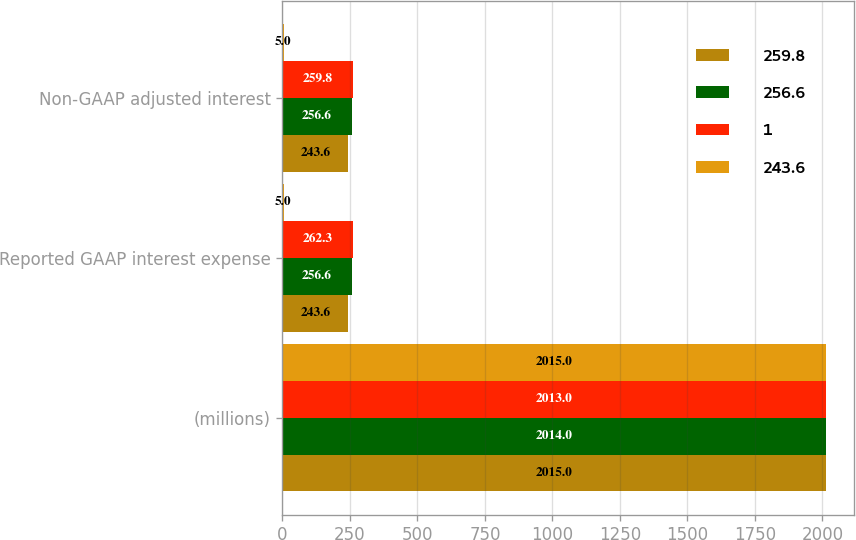Convert chart to OTSL. <chart><loc_0><loc_0><loc_500><loc_500><stacked_bar_chart><ecel><fcel>(millions)<fcel>Reported GAAP interest expense<fcel>Non-GAAP adjusted interest<nl><fcel>259.8<fcel>2015<fcel>243.6<fcel>243.6<nl><fcel>256.6<fcel>2014<fcel>256.6<fcel>256.6<nl><fcel>1<fcel>2013<fcel>262.3<fcel>259.8<nl><fcel>243.6<fcel>2015<fcel>5<fcel>5<nl></chart> 